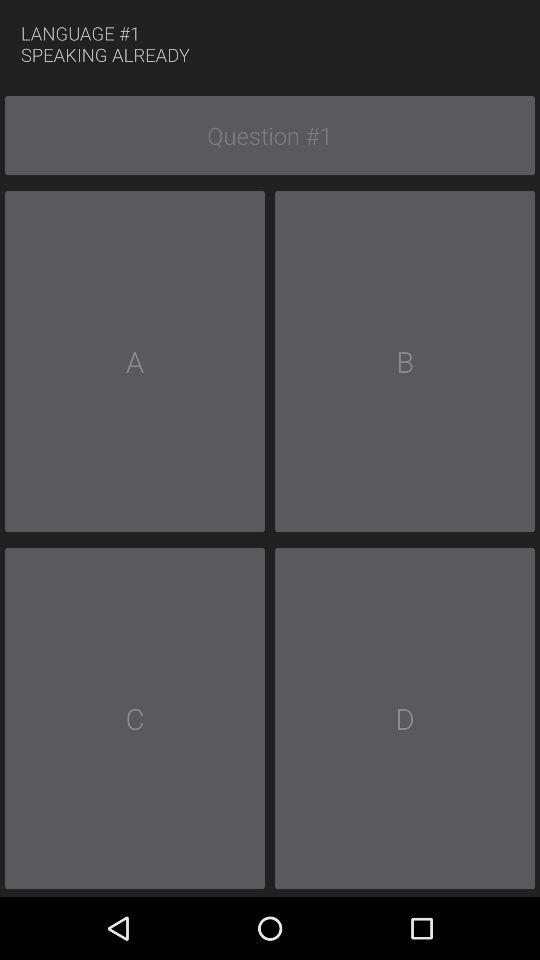What is the question number? The question number is 1. 